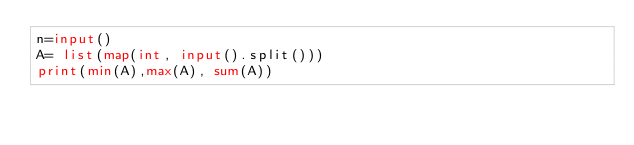Convert code to text. <code><loc_0><loc_0><loc_500><loc_500><_Python_>n=input()
A= list(map(int, input().split()))
print(min(A),max(A), sum(A))
</code> 